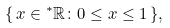Convert formula to latex. <formula><loc_0><loc_0><loc_500><loc_500>\{ \, x \in { ^ { * } \mathbb { R } } \colon 0 \leq x \leq 1 \, \} ,</formula> 